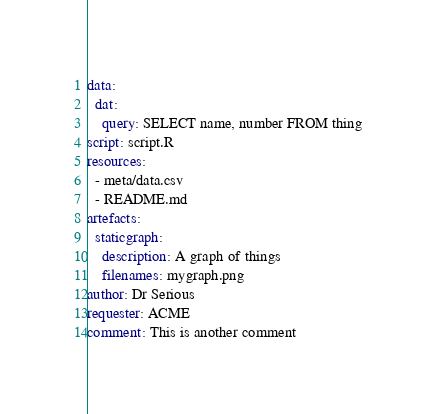Convert code to text. <code><loc_0><loc_0><loc_500><loc_500><_YAML_>data:
  dat:
    query: SELECT name, number FROM thing
script: script.R
resources:
  - meta/data.csv
  - README.md
artefacts:
  staticgraph:
    description: A graph of things
    filenames: mygraph.png
author: Dr Serious
requester: ACME
comment: This is another comment
</code> 